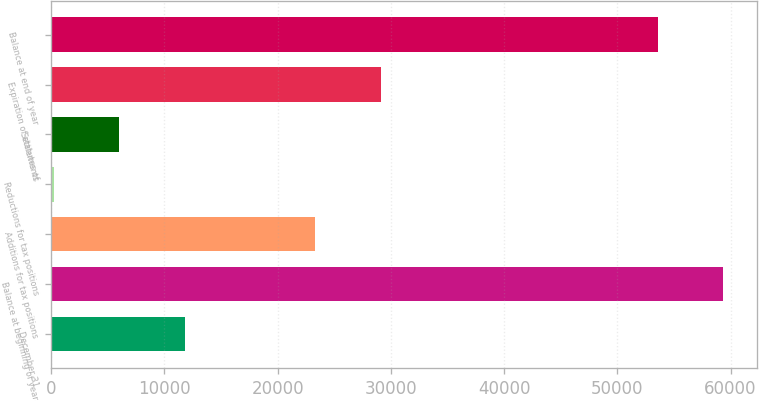Convert chart. <chart><loc_0><loc_0><loc_500><loc_500><bar_chart><fcel>December 31<fcel>Balance at beginning of year<fcel>Additions for tax positions<fcel>Reductions for tax positions<fcel>Settlements<fcel>Expiration of statutes of<fcel>Balance at end of year<nl><fcel>11768.8<fcel>59332.4<fcel>23327.6<fcel>210<fcel>5989.4<fcel>29107<fcel>53553<nl></chart> 